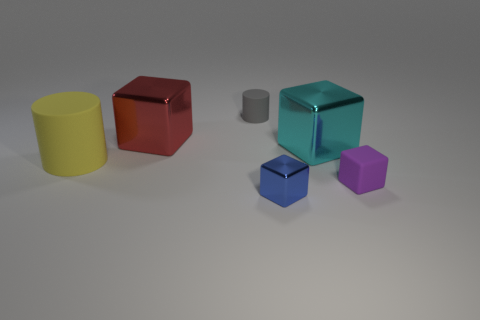Subtract 1 blocks. How many blocks are left? 3 Subtract all yellow blocks. Subtract all brown balls. How many blocks are left? 4 Add 2 big yellow objects. How many objects exist? 8 Subtract all cylinders. How many objects are left? 4 Add 3 tiny green metal cubes. How many tiny green metal cubes exist? 3 Subtract 0 purple spheres. How many objects are left? 6 Subtract all metal blocks. Subtract all big blue blocks. How many objects are left? 3 Add 4 cyan things. How many cyan things are left? 5 